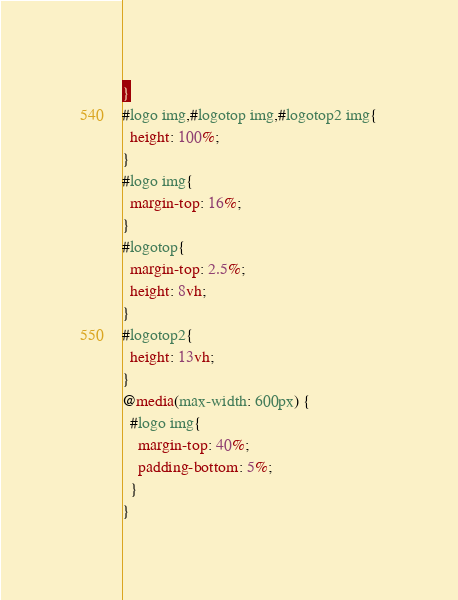<code> <loc_0><loc_0><loc_500><loc_500><_CSS_>}
#logo img,#logotop img,#logotop2 img{
  height: 100%;
}
#logo img{
  margin-top: 16%;
}
#logotop{
  margin-top: 2.5%;
  height: 8vh;
}
#logotop2{
  height: 13vh;
}
@media(max-width: 600px) {
  #logo img{
    margin-top: 40%;
    padding-bottom: 5%;
  }
}
</code> 